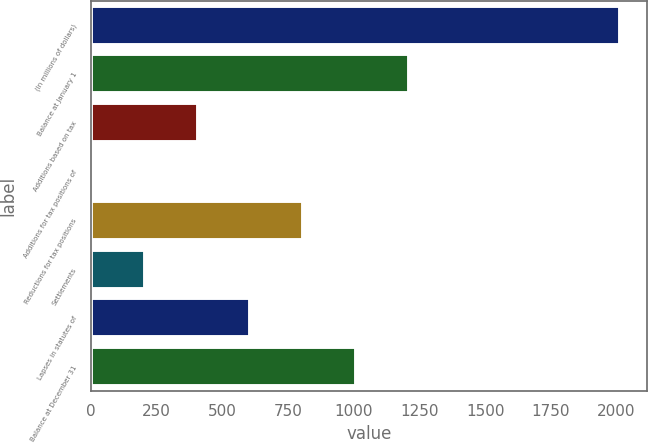Convert chart to OTSL. <chart><loc_0><loc_0><loc_500><loc_500><bar_chart><fcel>(In millions of dollars)<fcel>Balance at January 1<fcel>Additions based on tax<fcel>Additions for tax positions of<fcel>Reductions for tax positions<fcel>Settlements<fcel>Lapses in statutes of<fcel>Balance at December 31<nl><fcel>2014<fcel>1209.6<fcel>405.2<fcel>3<fcel>807.4<fcel>204.1<fcel>606.3<fcel>1008.5<nl></chart> 